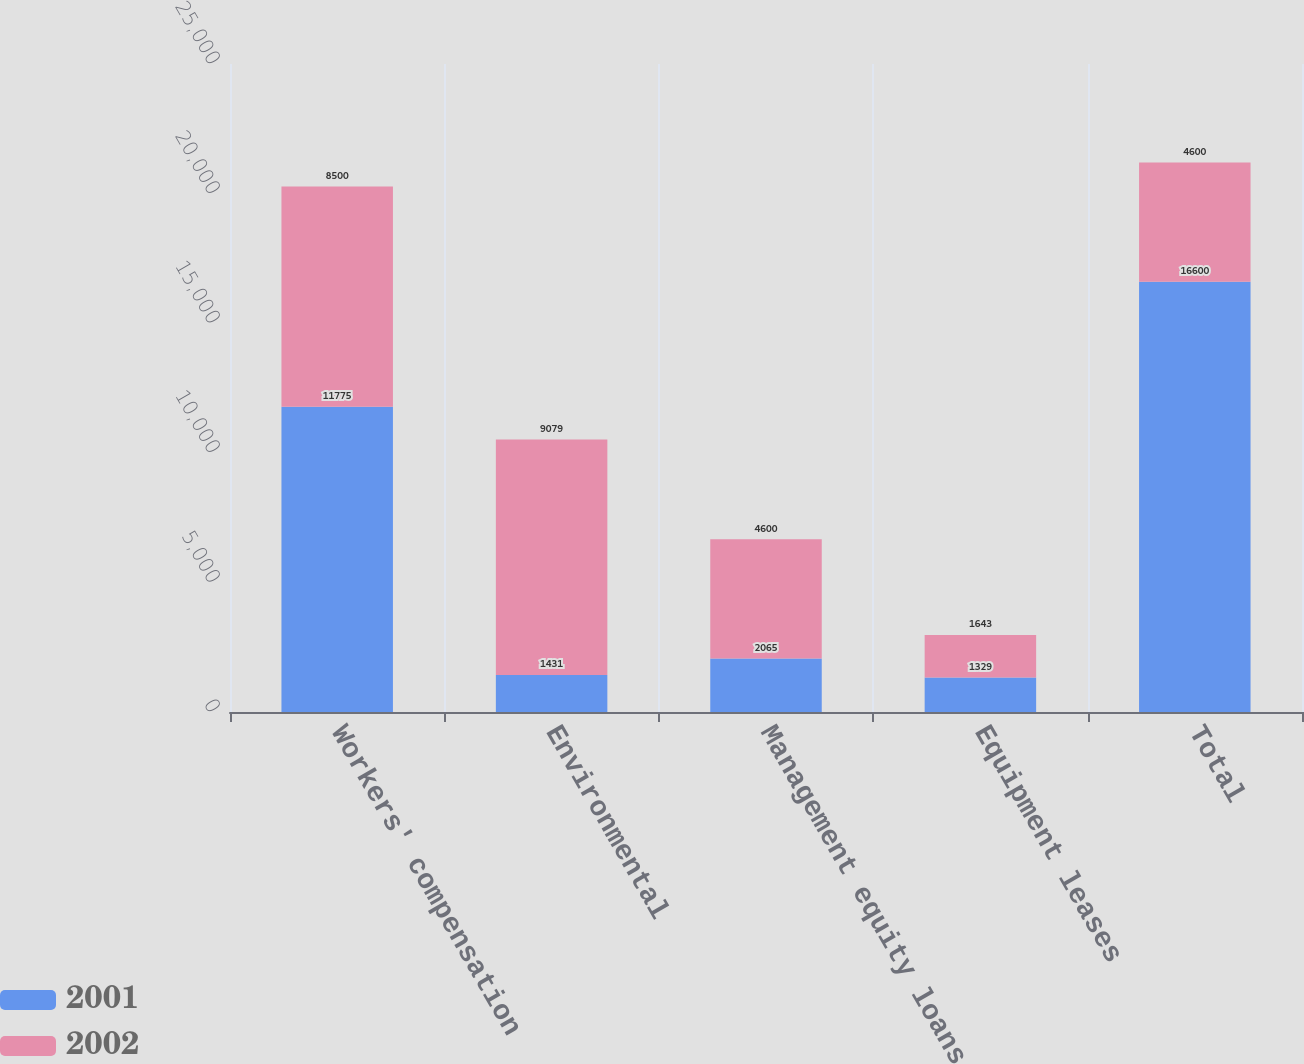<chart> <loc_0><loc_0><loc_500><loc_500><stacked_bar_chart><ecel><fcel>Workers' compensation<fcel>Environmental<fcel>Management equity loans<fcel>Equipment leases<fcel>Total<nl><fcel>2001<fcel>11775<fcel>1431<fcel>2065<fcel>1329<fcel>16600<nl><fcel>2002<fcel>8500<fcel>9079<fcel>4600<fcel>1643<fcel>4600<nl></chart> 